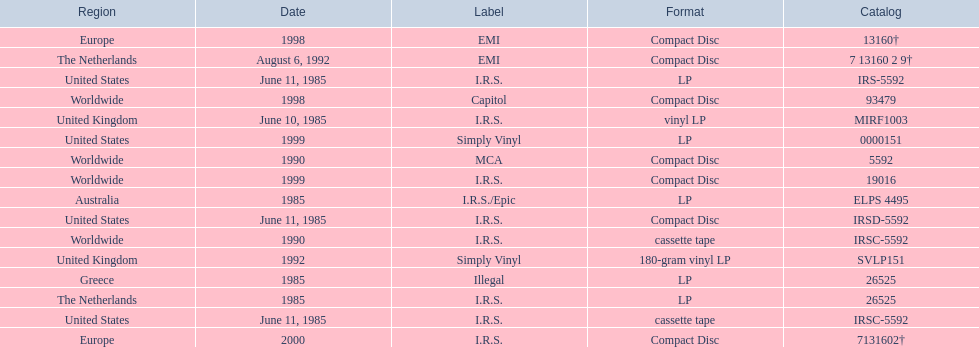In which regions was the fables of the reconstruction album released? United Kingdom, United States, United States, United States, Greece, Australia, The Netherlands, Worldwide, Worldwide, The Netherlands, United Kingdom, Worldwide, Europe, Worldwide, United States, Europe. And what were the release dates for those regions? June 10, 1985, June 11, 1985, June 11, 1985, June 11, 1985, 1985, 1985, 1985, 1990, 1990, August 6, 1992, 1992, 1998, 1998, 1999, 1999, 2000. And which region was listed after greece in 1985? Australia. 